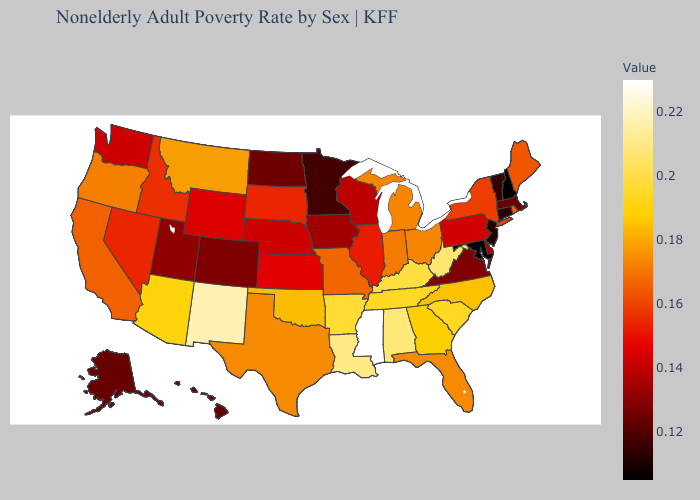Does California have the lowest value in the West?
Keep it brief. No. Among the states that border Florida , which have the highest value?
Short answer required. Alabama. Does North Carolina have a higher value than Alabama?
Short answer required. No. Which states hav the highest value in the South?
Quick response, please. Mississippi. Is the legend a continuous bar?
Quick response, please. Yes. 